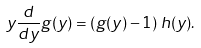<formula> <loc_0><loc_0><loc_500><loc_500>y \frac { d } { d y } g ( y ) = \left ( g ( y ) - 1 \right ) \, h ( y ) .</formula> 